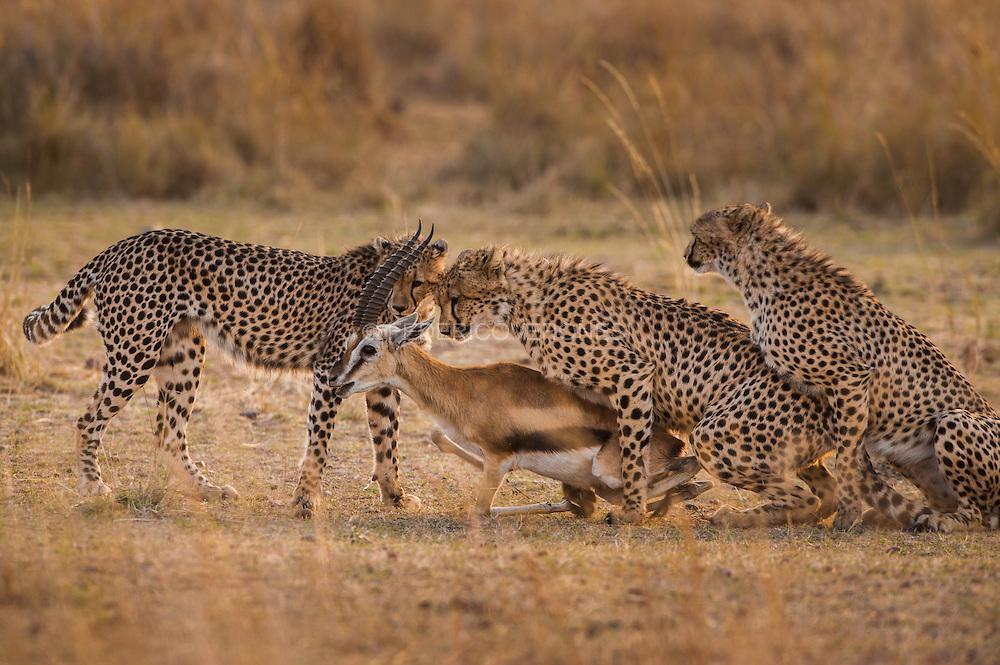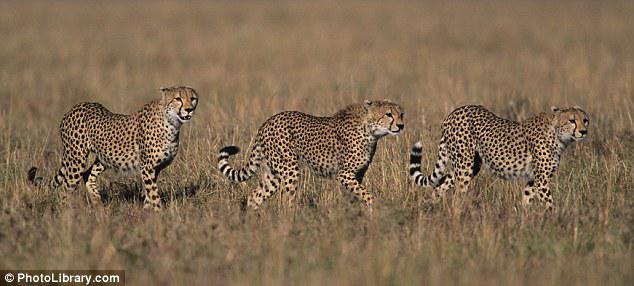The first image is the image on the left, the second image is the image on the right. Examine the images to the left and right. Is the description "A wild cat with front paws extended is pouncing on visible prey in one image." accurate? Answer yes or no. No. The first image is the image on the left, the second image is the image on the right. Considering the images on both sides, is "There are exactly three animals in the image on the right." valid? Answer yes or no. Yes. 